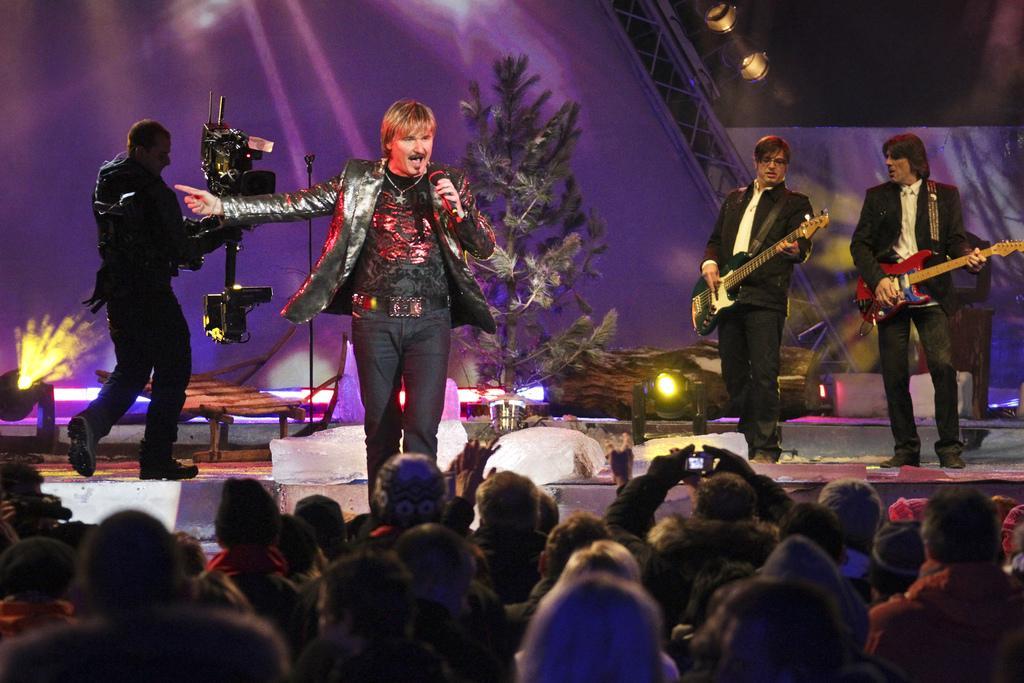How would you summarize this image in a sentence or two? In this image I can see group of people standing. In front the person is wearing black color dress and holding a microphone and singing. Background I can see two persons playing musical instruments and a person holding a camera and plants in green color and I can see few lights. 